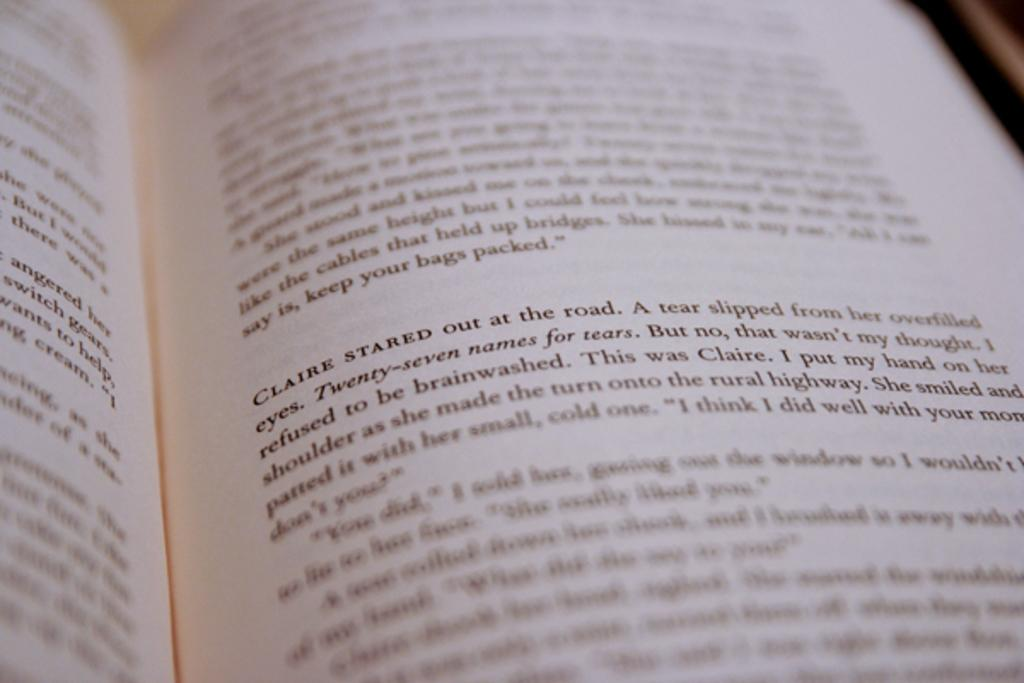<image>
Render a clear and concise summary of the photo. a book open to a page where one paragraph starts with claire stared 